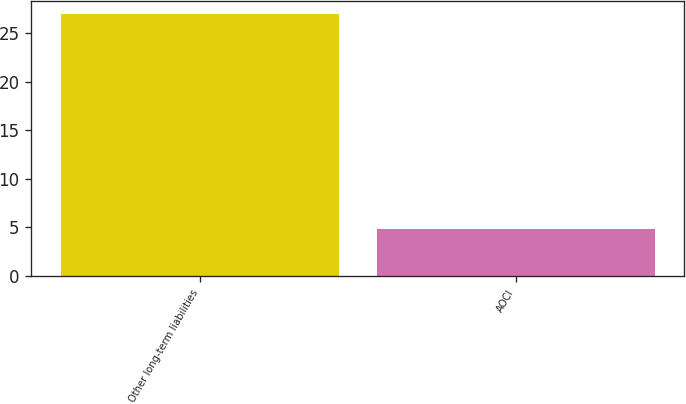Convert chart to OTSL. <chart><loc_0><loc_0><loc_500><loc_500><bar_chart><fcel>Other long-term liabilities<fcel>AOCI<nl><fcel>27<fcel>4.8<nl></chart> 